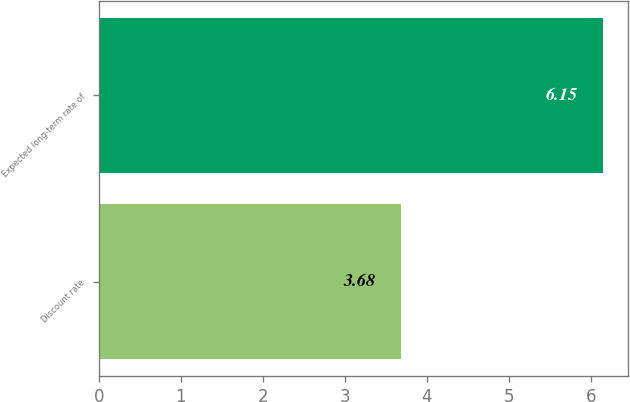Convert chart. <chart><loc_0><loc_0><loc_500><loc_500><bar_chart><fcel>Discount rate<fcel>Expected long-term rate of<nl><fcel>3.68<fcel>6.15<nl></chart> 